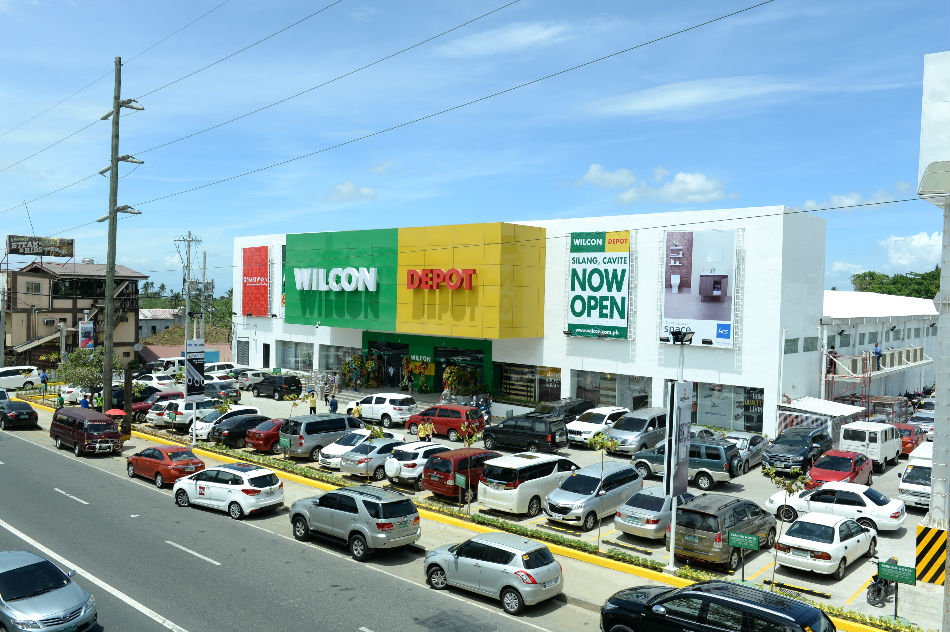Could the presence of so many cars and people provide any insights into the time of day or week when this photo was taken? The considerable number of cars and people suggests that the photo was likely taken during a busy time, possibly on a weekend or during the opening day of the establishment. The bright lighting and clear sky also hint that it could be during daylight hours, perhaps late morning or early afternoon when people are more likely to be out shopping. 